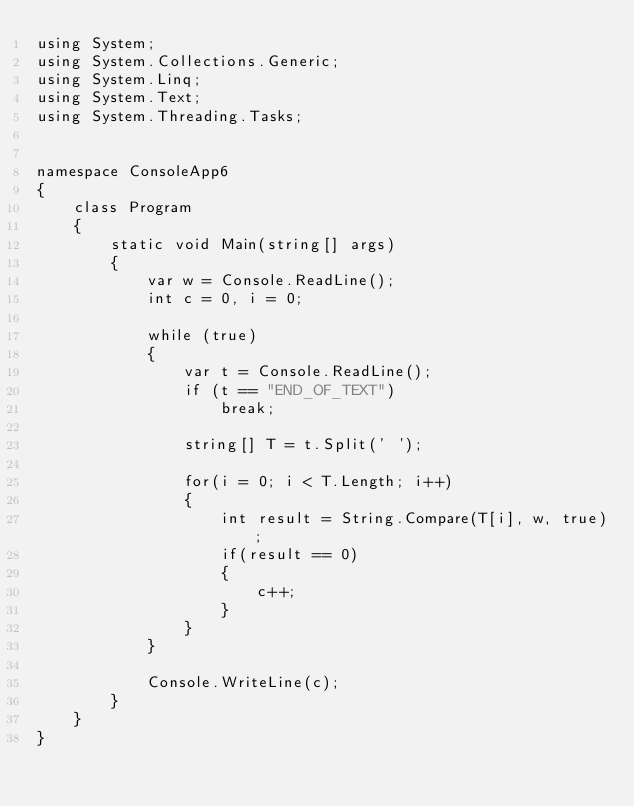Convert code to text. <code><loc_0><loc_0><loc_500><loc_500><_C#_>using System;
using System.Collections.Generic;
using System.Linq;
using System.Text;
using System.Threading.Tasks;


namespace ConsoleApp6
{
	class Program
	{
		static void Main(string[] args)
		{
			var w = Console.ReadLine();
			int c = 0, i = 0;

			while (true)
			{
				var t = Console.ReadLine();
				if (t == "END_OF_TEXT")
					break;

				string[] T = t.Split(' ');

				for(i = 0; i < T.Length; i++)
				{
					int result = String.Compare(T[i], w, true);
					if(result == 0)
					{
						c++;
					}
				}
			}

			Console.WriteLine(c);
		}
	}
}

</code> 